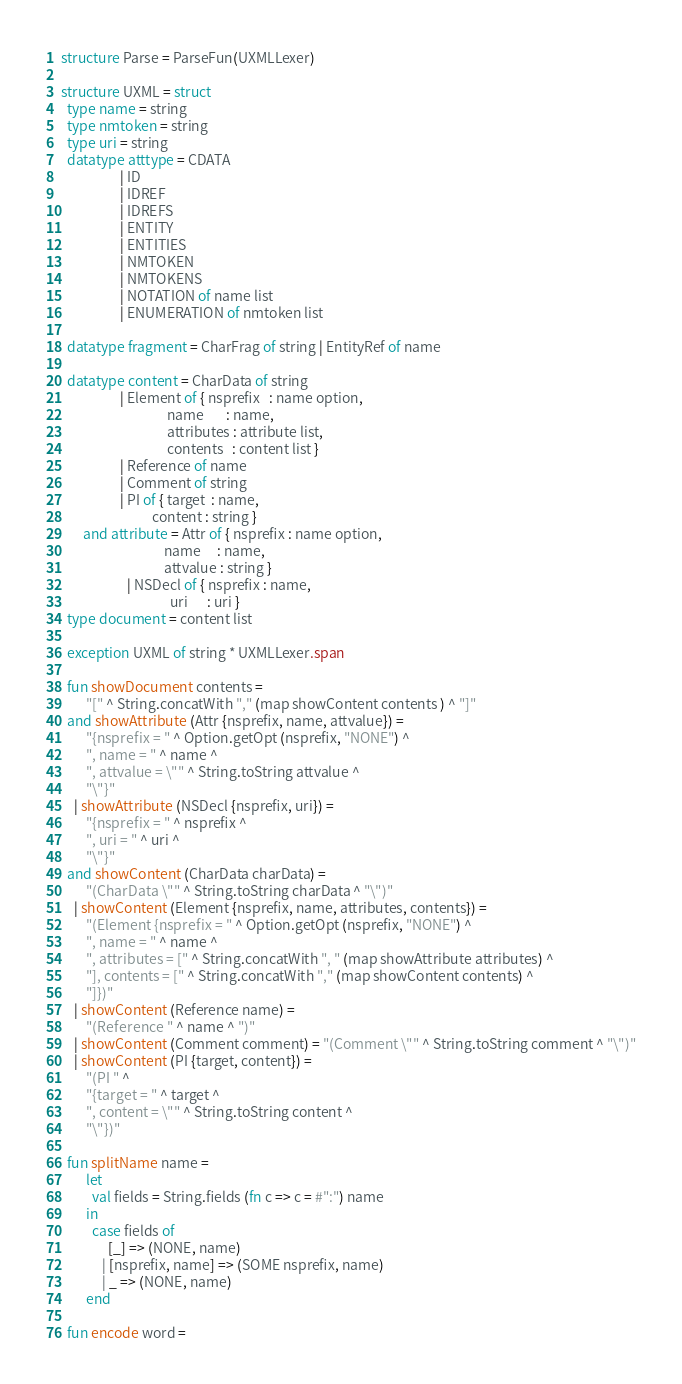Convert code to text. <code><loc_0><loc_0><loc_500><loc_500><_SML_>structure Parse = ParseFun(UXMLLexer)

structure UXML = struct
  type name = string
  type nmtoken = string
  type uri = string
  datatype atttype = CDATA
                   | ID
                   | IDREF
                   | IDREFS
                   | ENTITY
                   | ENTITIES
                   | NMTOKEN
                   | NMTOKENS
                   | NOTATION of name list
                   | ENUMERATION of nmtoken list

  datatype fragment = CharFrag of string | EntityRef of name

  datatype content = CharData of string
                   | Element of { nsprefix   : name option,
                                  name       : name,
                                  attributes : attribute list,
                                  contents   : content list }
                   | Reference of name
                   | Comment of string
                   | PI of { target  : name,
                             content : string }
       and attribute = Attr of { nsprefix : name option,
                                 name     : name,
                                 attvalue : string }
                     | NSDecl of { nsprefix : name,
                                   uri      : uri }
  type document = content list

  exception UXML of string * UXMLLexer.span

  fun showDocument contents =
        "[" ^ String.concatWith "," (map showContent contents ) ^ "]"
  and showAttribute (Attr {nsprefix, name, attvalue}) =
        "{nsprefix = " ^ Option.getOpt (nsprefix, "NONE") ^
        ", name = " ^ name ^
        ", attvalue = \"" ^ String.toString attvalue ^
        "\"}"
    | showAttribute (NSDecl {nsprefix, uri}) =
        "{nsprefix = " ^ nsprefix ^
        ", uri = " ^ uri ^
        "\"}"
  and showContent (CharData charData) =
        "(CharData \"" ^ String.toString charData ^ "\")"
    | showContent (Element {nsprefix, name, attributes, contents}) =
        "(Element {nsprefix = " ^ Option.getOpt (nsprefix, "NONE") ^
        ", name = " ^ name ^
        ", attributes = [" ^ String.concatWith ", " (map showAttribute attributes) ^
        "], contents = [" ^ String.concatWith "," (map showContent contents) ^
        "]})"
    | showContent (Reference name) =
        "(Reference " ^ name ^ ")"
    | showContent (Comment comment) = "(Comment \"" ^ String.toString comment ^ "\")"
    | showContent (PI {target, content}) =
        "(PI " ^
        "{target = " ^ target ^
        ", content = \"" ^ String.toString content ^
        "\"})"

  fun splitName name =
        let
          val fields = String.fields (fn c => c = #":") name
        in
          case fields of
               [_] => (NONE, name)
             | [nsprefix, name] => (SOME nsprefix, name)
             | _ => (NONE, name)
        end

  fun encode word =</code> 